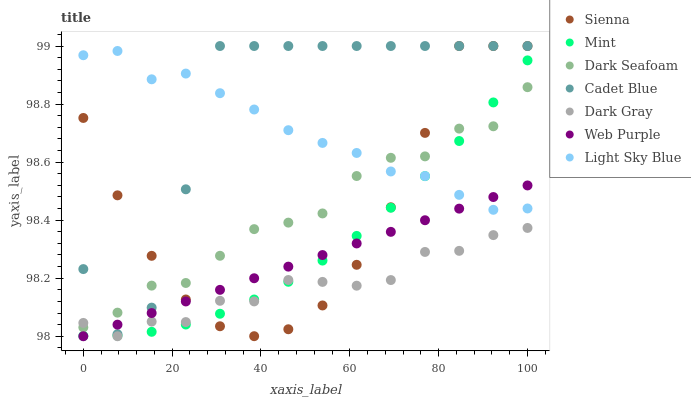Does Dark Gray have the minimum area under the curve?
Answer yes or no. Yes. Does Cadet Blue have the maximum area under the curve?
Answer yes or no. Yes. Does Web Purple have the minimum area under the curve?
Answer yes or no. No. Does Web Purple have the maximum area under the curve?
Answer yes or no. No. Is Web Purple the smoothest?
Answer yes or no. Yes. Is Cadet Blue the roughest?
Answer yes or no. Yes. Is Cadet Blue the smoothest?
Answer yes or no. No. Is Web Purple the roughest?
Answer yes or no. No. Does Dark Gray have the lowest value?
Answer yes or no. Yes. Does Cadet Blue have the lowest value?
Answer yes or no. No. Does Sienna have the highest value?
Answer yes or no. Yes. Does Web Purple have the highest value?
Answer yes or no. No. Is Mint less than Cadet Blue?
Answer yes or no. Yes. Is Cadet Blue greater than Dark Gray?
Answer yes or no. Yes. Does Mint intersect Dark Seafoam?
Answer yes or no. Yes. Is Mint less than Dark Seafoam?
Answer yes or no. No. Is Mint greater than Dark Seafoam?
Answer yes or no. No. Does Mint intersect Cadet Blue?
Answer yes or no. No. 